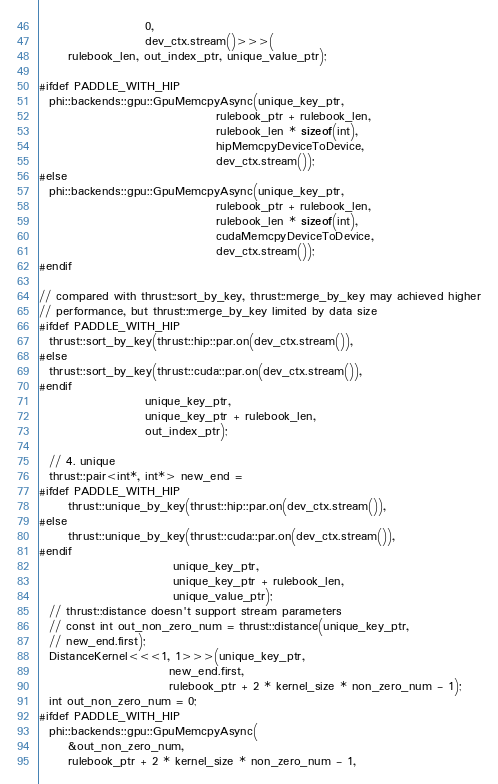<code> <loc_0><loc_0><loc_500><loc_500><_Cuda_>                      0,
                      dev_ctx.stream()>>>(
      rulebook_len, out_index_ptr, unique_value_ptr);

#ifdef PADDLE_WITH_HIP
  phi::backends::gpu::GpuMemcpyAsync(unique_key_ptr,
                                     rulebook_ptr + rulebook_len,
                                     rulebook_len * sizeof(int),
                                     hipMemcpyDeviceToDevice,
                                     dev_ctx.stream());
#else
  phi::backends::gpu::GpuMemcpyAsync(unique_key_ptr,
                                     rulebook_ptr + rulebook_len,
                                     rulebook_len * sizeof(int),
                                     cudaMemcpyDeviceToDevice,
                                     dev_ctx.stream());
#endif

// compared with thrust::sort_by_key, thrust::merge_by_key may achieved higher
// performance, but thrust::merge_by_key limited by data size
#ifdef PADDLE_WITH_HIP
  thrust::sort_by_key(thrust::hip::par.on(dev_ctx.stream()),
#else
  thrust::sort_by_key(thrust::cuda::par.on(dev_ctx.stream()),
#endif
                      unique_key_ptr,
                      unique_key_ptr + rulebook_len,
                      out_index_ptr);

  // 4. unique
  thrust::pair<int*, int*> new_end =
#ifdef PADDLE_WITH_HIP
      thrust::unique_by_key(thrust::hip::par.on(dev_ctx.stream()),
#else
      thrust::unique_by_key(thrust::cuda::par.on(dev_ctx.stream()),
#endif
                            unique_key_ptr,
                            unique_key_ptr + rulebook_len,
                            unique_value_ptr);
  // thrust::distance doesn't support stream parameters
  // const int out_non_zero_num = thrust::distance(unique_key_ptr,
  // new_end.first);
  DistanceKernel<<<1, 1>>>(unique_key_ptr,
                           new_end.first,
                           rulebook_ptr + 2 * kernel_size * non_zero_num - 1);
  int out_non_zero_num = 0;
#ifdef PADDLE_WITH_HIP
  phi::backends::gpu::GpuMemcpyAsync(
      &out_non_zero_num,
      rulebook_ptr + 2 * kernel_size * non_zero_num - 1,</code> 